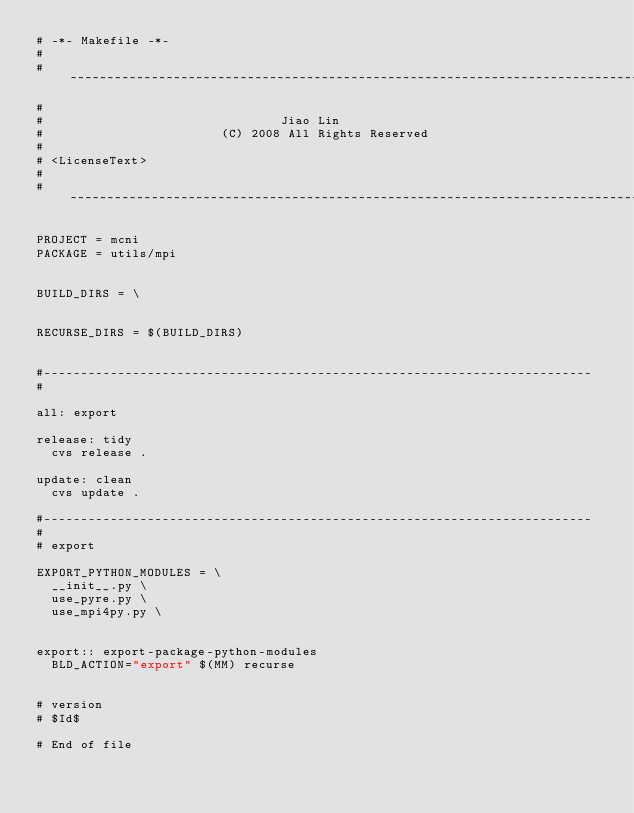Convert code to text. <code><loc_0><loc_0><loc_500><loc_500><_ObjectiveC_># -*- Makefile -*-
#
# ~~~~~~~~~~~~~~~~~~~~~~~~~~~~~~~~~~~~~~~~~~~~~~~~~~~~~~~~~~~~~~~~~~~~~~~~~~~~~
#
#                                Jiao Lin
#                        (C) 2008 All Rights Reserved
#
# <LicenseText>
#
# ~~~~~~~~~~~~~~~~~~~~~~~~~~~~~~~~~~~~~~~~~~~~~~~~~~~~~~~~~~~~~~~~~~~~~~~~~~~~~

PROJECT = mcni
PACKAGE = utils/mpi


BUILD_DIRS = \


RECURSE_DIRS = $(BUILD_DIRS)


#--------------------------------------------------------------------------
#

all: export

release: tidy
	cvs release .

update: clean
	cvs update .

#--------------------------------------------------------------------------
#
# export

EXPORT_PYTHON_MODULES = \
	__init__.py \
	use_pyre.py \
	use_mpi4py.py \


export:: export-package-python-modules
	BLD_ACTION="export" $(MM) recurse


# version
# $Id$

# End of file
</code> 